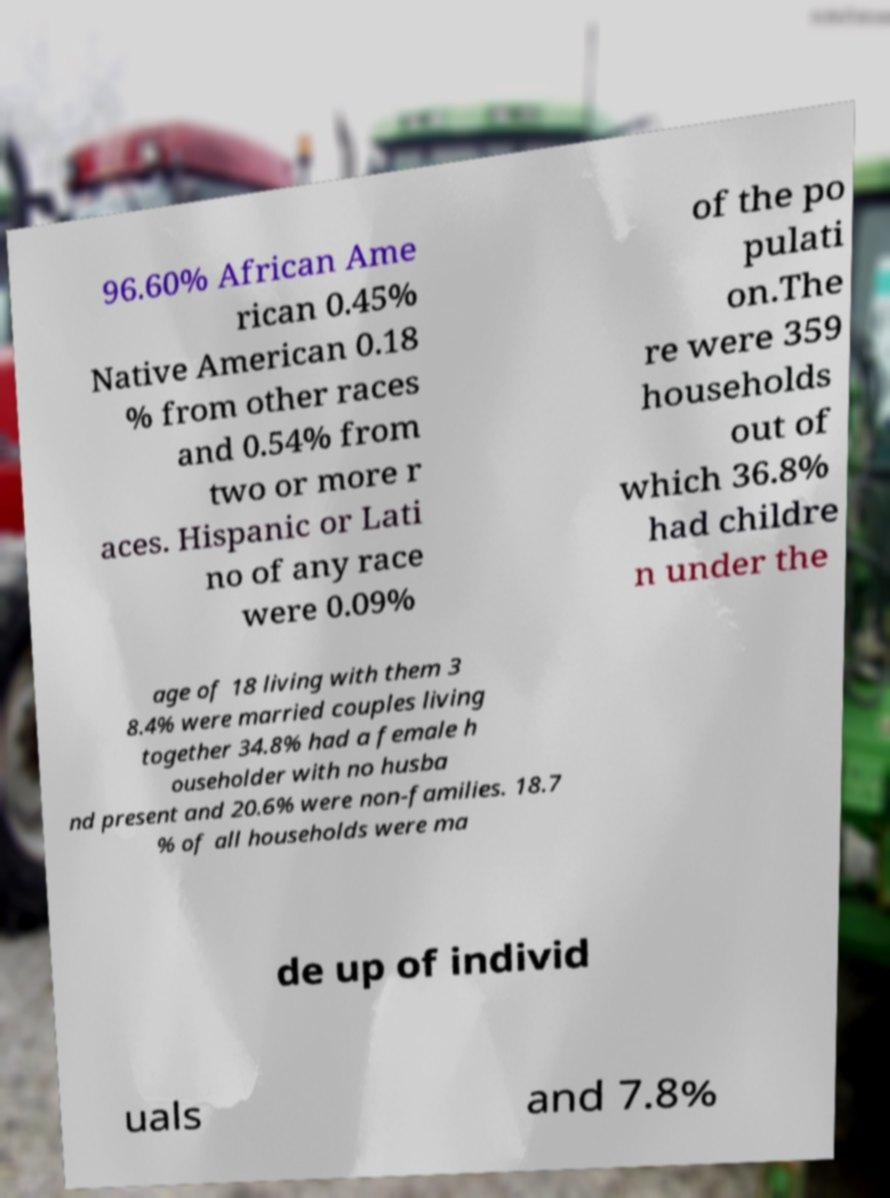What messages or text are displayed in this image? I need them in a readable, typed format. 96.60% African Ame rican 0.45% Native American 0.18 % from other races and 0.54% from two or more r aces. Hispanic or Lati no of any race were 0.09% of the po pulati on.The re were 359 households out of which 36.8% had childre n under the age of 18 living with them 3 8.4% were married couples living together 34.8% had a female h ouseholder with no husba nd present and 20.6% were non-families. 18.7 % of all households were ma de up of individ uals and 7.8% 